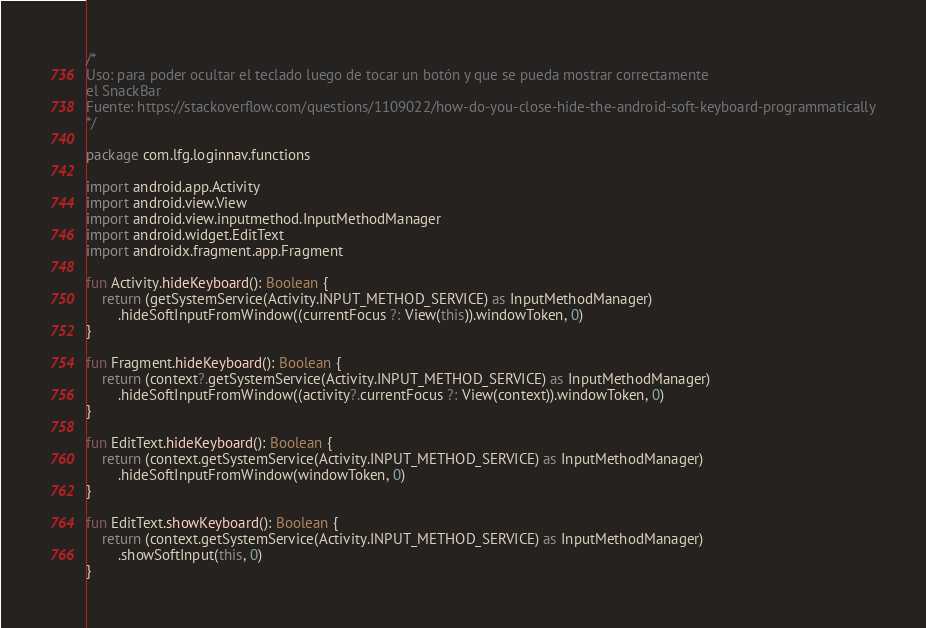<code> <loc_0><loc_0><loc_500><loc_500><_Kotlin_>/*
Uso: para poder ocultar el teclado luego de tocar un botón y que se pueda mostrar correctamente
el SnackBar
Fuente: https://stackoverflow.com/questions/1109022/how-do-you-close-hide-the-android-soft-keyboard-programmatically
*/

package com.lfg.loginnav.functions

import android.app.Activity
import android.view.View
import android.view.inputmethod.InputMethodManager
import android.widget.EditText
import androidx.fragment.app.Fragment

fun Activity.hideKeyboard(): Boolean {
    return (getSystemService(Activity.INPUT_METHOD_SERVICE) as InputMethodManager)
        .hideSoftInputFromWindow((currentFocus ?: View(this)).windowToken, 0)
}

fun Fragment.hideKeyboard(): Boolean {
    return (context?.getSystemService(Activity.INPUT_METHOD_SERVICE) as InputMethodManager)
        .hideSoftInputFromWindow((activity?.currentFocus ?: View(context)).windowToken, 0)
}

fun EditText.hideKeyboard(): Boolean {
    return (context.getSystemService(Activity.INPUT_METHOD_SERVICE) as InputMethodManager)
        .hideSoftInputFromWindow(windowToken, 0)
}

fun EditText.showKeyboard(): Boolean {
    return (context.getSystemService(Activity.INPUT_METHOD_SERVICE) as InputMethodManager)
        .showSoftInput(this, 0)
}
</code> 